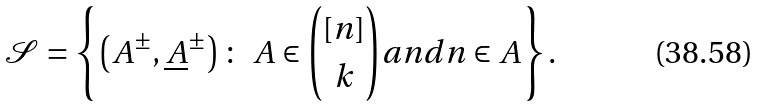<formula> <loc_0><loc_0><loc_500><loc_500>\mathcal { S } = \left \{ \left ( A ^ { \pm } , \underline { A } ^ { \pm } \right ) \colon \ A \in \binom { [ n ] } { k } a n d n \in A \right \} .</formula> 